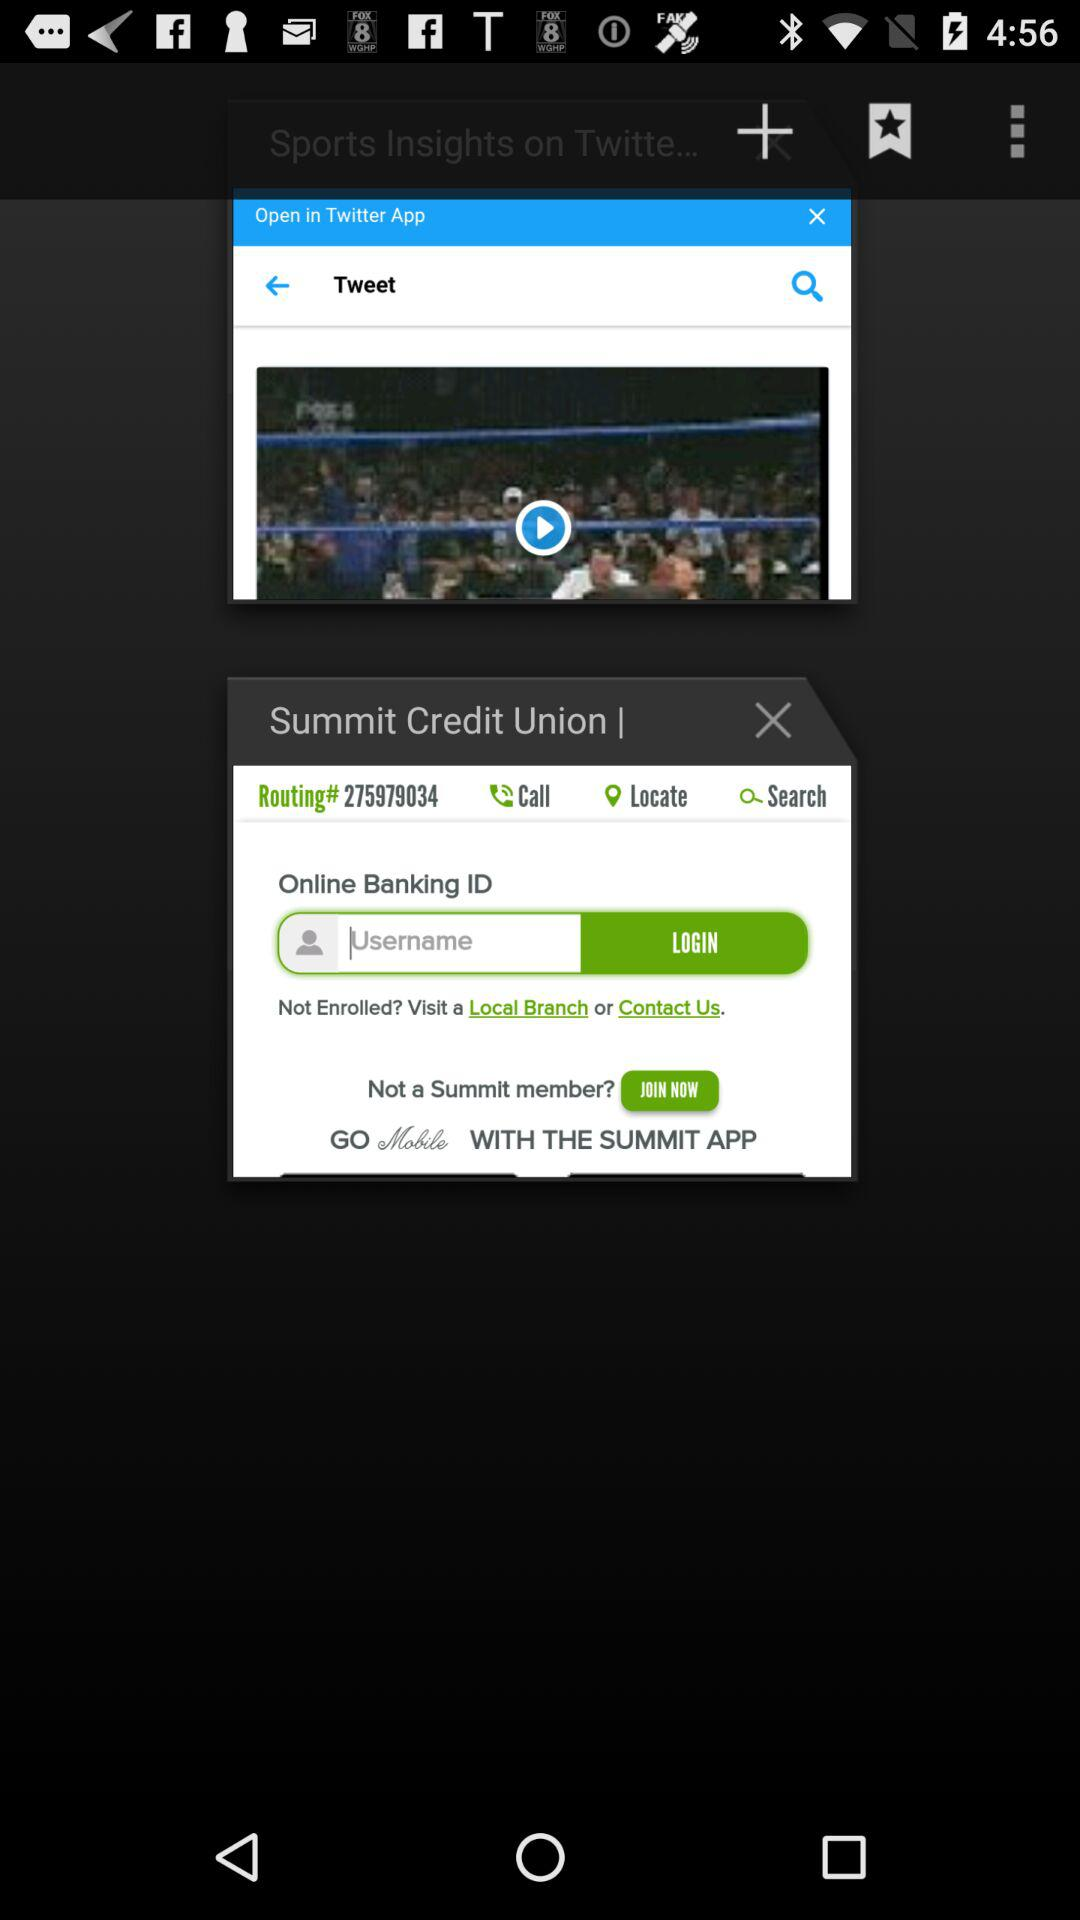What's the routing number? The routing number is 275979034. 